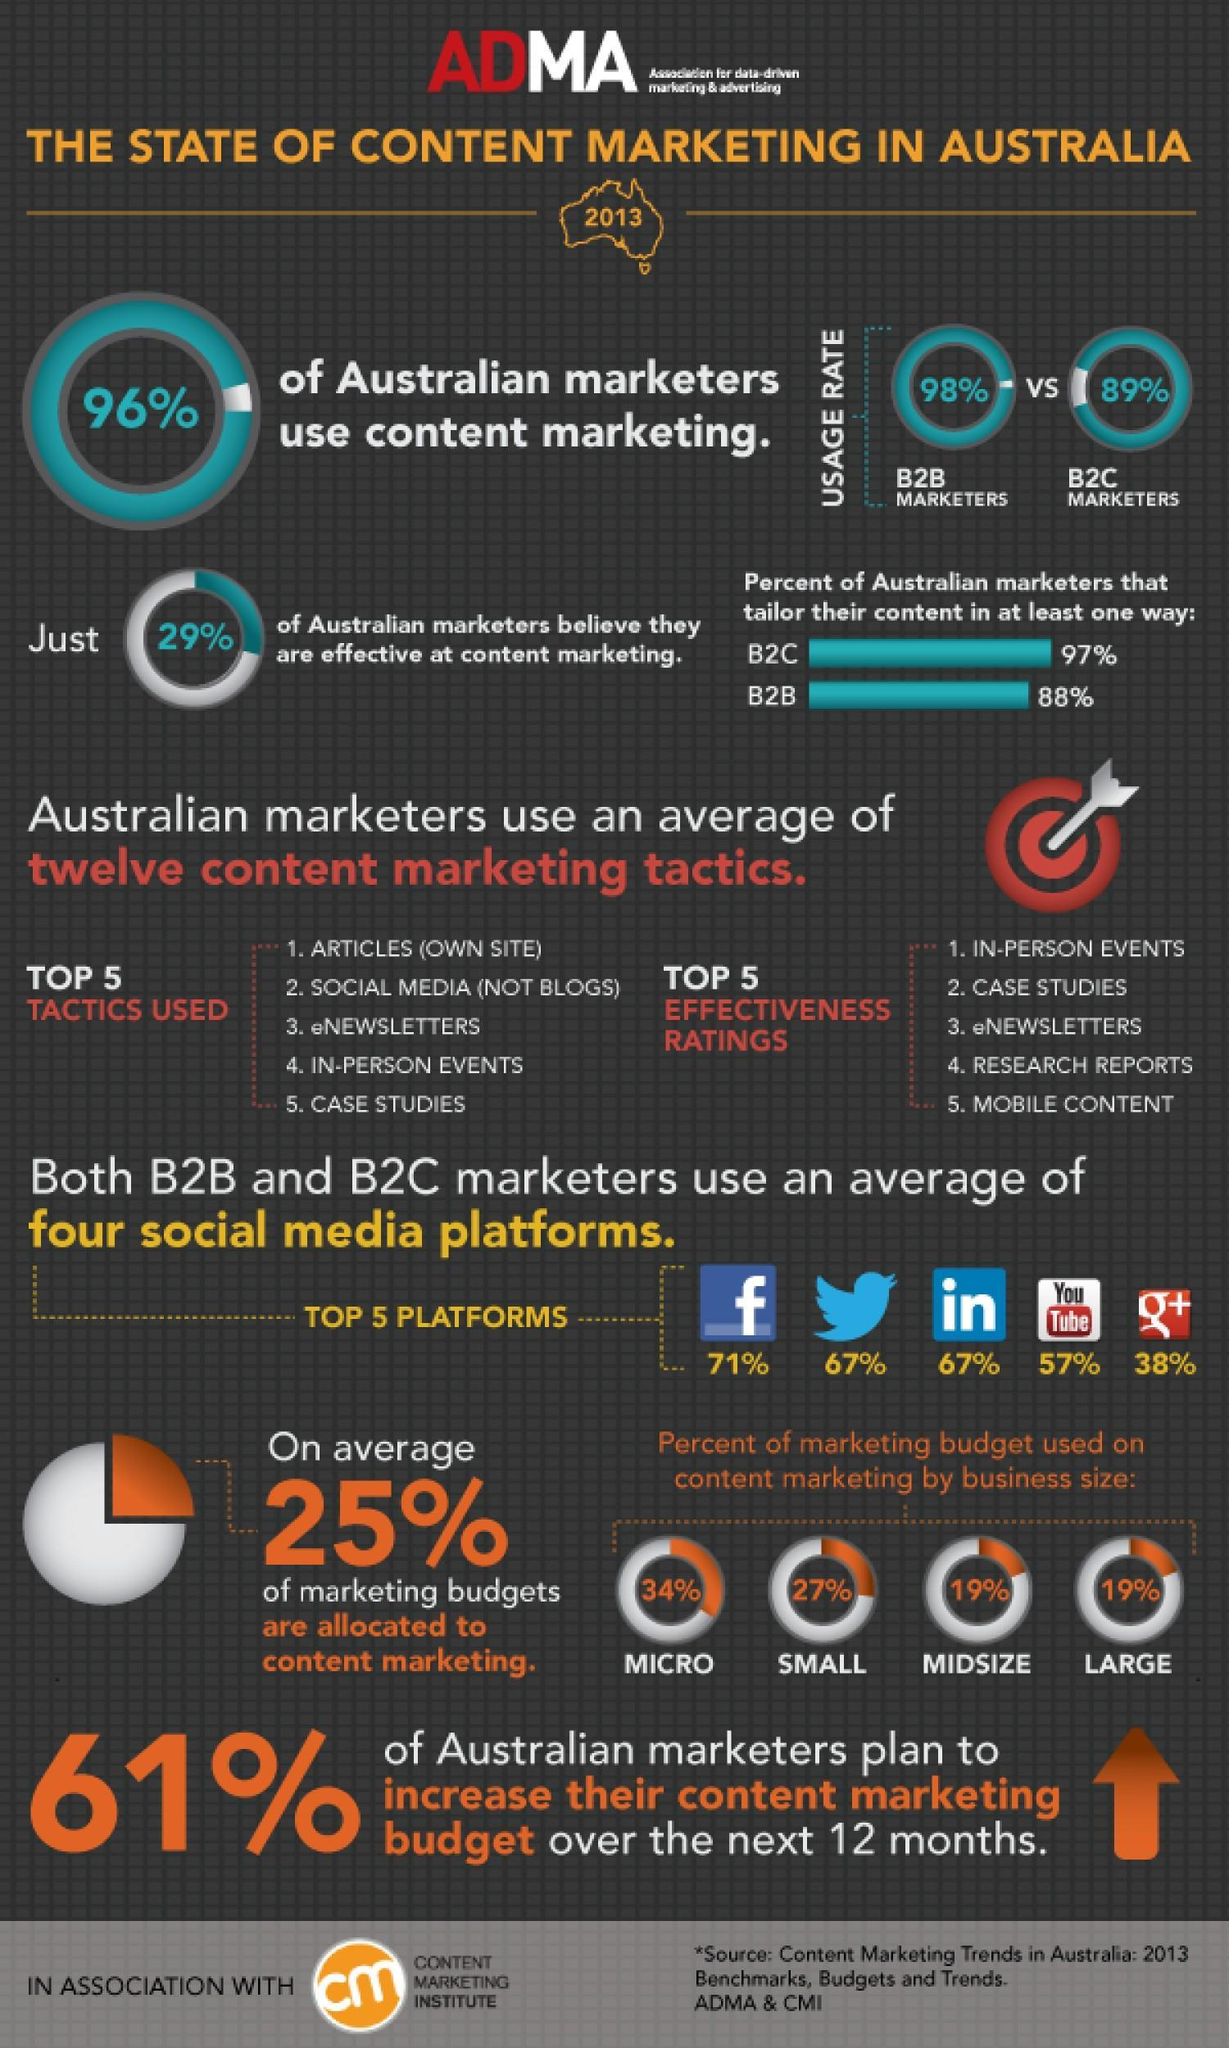How much of the marketing budget is used by micro businesses?
Answer the question with a short phrase. 34% Which sized businesses use 27% of the marketing budget? small What percentage of B2B marketers use content marketing? 98% What percent of marketers use LinkedIn? 67% How much of marketing budget is allocated to content marketing? 25% How many of the marketers use YouTube? 57% 